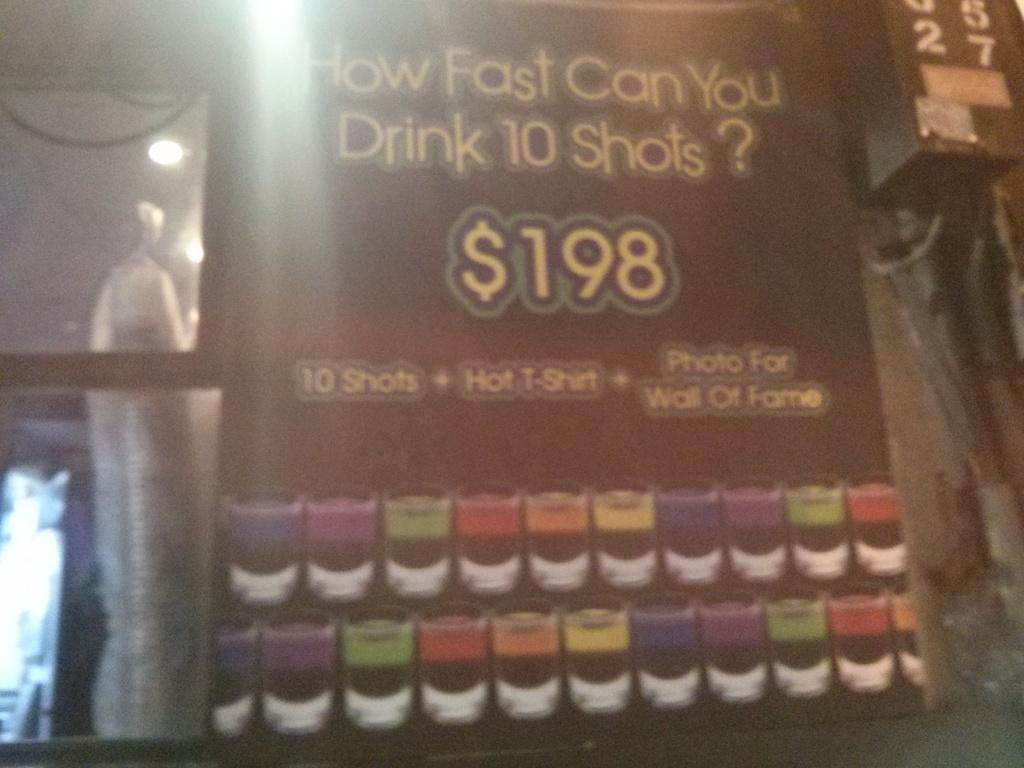<image>
Relay a brief, clear account of the picture shown. An advertisement asking "How Fast Can You Drink 10 Shots?" 